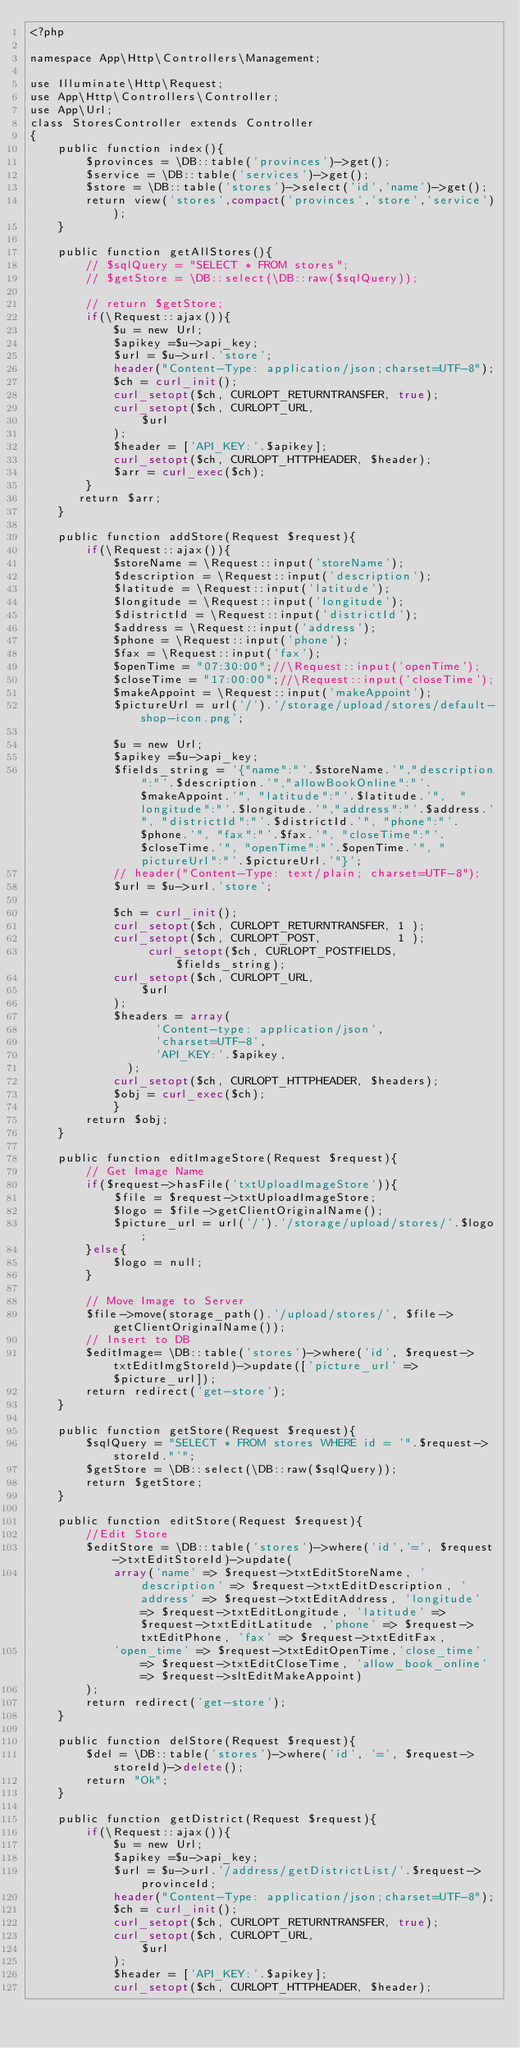Convert code to text. <code><loc_0><loc_0><loc_500><loc_500><_PHP_><?php

namespace App\Http\Controllers\Management;

use Illuminate\Http\Request;
use App\Http\Controllers\Controller;
use App\Url;
class StoresController extends Controller
{
    public function index(){
        $provinces = \DB::table('provinces')->get();
        $service = \DB::table('services')->get();
        $store = \DB::table('stores')->select('id','name')->get();
        return view('stores',compact('provinces','store','service'));
    }    

    public function getAllStores(){
        // $sqlQuery = "SELECT * FROM stores";
        // $getStore = \DB::select(\DB::raw($sqlQuery));             
        
        // return $getStore;
        if(\Request::ajax()){
            $u = new Url;
            $apikey =$u->api_key;
            $url = $u->url.'store';
            header("Content-Type: application/json;charset=UTF-8");              
            $ch = curl_init();
            curl_setopt($ch, CURLOPT_RETURNTRANSFER, true);
            curl_setopt($ch, CURLOPT_URL,
                $url
            );
            $header = ['API_KEY:'.$apikey];
            curl_setopt($ch, CURLOPT_HTTPHEADER, $header);
            $arr = curl_exec($ch);
        }
       return $arr;
    }

    public function addStore(Request $request){
        if(\Request::ajax()){
            $storeName = \Request::input('storeName');
            $description = \Request::input('description');
            $latitude = \Request::input('latitude');
            $longitude = \Request::input('longitude');
            $districtId = \Request::input('districtId');
            $address = \Request::input('address');
            $phone = \Request::input('phone');
            $fax = \Request::input('fax');
            $openTime = "07:30:00";//\Request::input('openTime');
            $closeTime = "17:00:00";//\Request::input('closeTime');
            $makeAppoint = \Request::input('makeAppoint');  
            $pictureUrl = url('/').'/storage/upload/stores/default-shop-icon.png';
            
            $u = new Url;
            $apikey =$u->api_key;
            $fields_string = '{"name":"'.$storeName.'","description":"'.$description.'","allowBookOnline":"'.$makeAppoint.'", "latitude":"'.$latitude.'",  "longitude":"'.$longitude.'","address":"'.$address.'", "districtId":"'.$districtId.'", "phone":"'.$phone.'", "fax":"'.$fax.'", "closeTime":"'.$closeTime.'", "openTime":"'.$openTime.'", "pictureUrl":"'.$pictureUrl.'"}';                   
            // header("Content-Type: text/plain; charset=UTF-8");
            $url = $u->url.'store';
     
            $ch = curl_init();
            curl_setopt($ch, CURLOPT_RETURNTRANSFER, 1 );
            curl_setopt($ch, CURLOPT_POST,           1 );
                 curl_setopt($ch, CURLOPT_POSTFIELDS, $fields_string);
            curl_setopt($ch, CURLOPT_URL,
                $url
            );
            $headers = array(
                  'Content-type: application/json',
                  'charset=UTF-8',
                  'API_KEY:'.$apikey,
              );
            curl_setopt($ch, CURLOPT_HTTPHEADER, $headers);
            $obj = curl_exec($ch);
            }
        return $obj;
    }

    public function editImageStore(Request $request){
        // Get Image Name
        if($request->hasFile('txtUploadImageStore')){
            $file = $request->txtUploadImageStore;            
            $logo = $file->getClientOriginalName();
            $picture_url = url('/').'/storage/upload/stores/'.$logo;
        }else{
            $logo = null;
        }
        
        // Move Image to Server
        $file->move(storage_path().'/upload/stores/', $file->getClientOriginalName());
        // Insert to DB
        $editImage= \DB::table('stores')->where('id', $request->txtEditImgStoreId)->update(['picture_url' => $picture_url]);
        return redirect('get-store');     
    }

    public function getStore(Request $request){
        $sqlQuery = "SELECT * FROM stores WHERE id = '".$request->storeId."'";
        $getStore = \DB::select(\DB::raw($sqlQuery));                                    
        return $getStore;
    }

    public function editStore(Request $request){     
        //Edit Store
        $editStore = \DB::table('stores')->where('id','=', $request->txtEditStoreId)->update(
            array('name' => $request->txtEditStoreName, 'description' => $request->txtEditDescription, 'address' => $request->txtEditAddress, 'longitude' => $request->txtEditLongitude, 'latitude' => $request->txtEditLatitude ,'phone' => $request->txtEditPhone, 'fax' => $request->txtEditFax,
            'open_time' => $request->txtEditOpenTime,'close_time' => $request->txtEditCloseTime, 'allow_book_online' => $request->sltEditMakeAppoint)
        );       
        return redirect('get-store');
    }

    public function delStore(Request $request){
        $del = \DB::table('stores')->where('id', '=', $request->storeId)->delete();
        return "Ok";
    }

    public function getDistrict(Request $request){
        if(\Request::ajax()){
            $u = new Url;
            $apikey =$u->api_key;
            $url = $u->url.'/address/getDistrictList/'.$request->provinceId;
            header("Content-Type: application/json;charset=UTF-8");              
            $ch = curl_init();
            curl_setopt($ch, CURLOPT_RETURNTRANSFER, true);
            curl_setopt($ch, CURLOPT_URL,
                $url
            );
            $header = ['API_KEY:'.$apikey];
            curl_setopt($ch, CURLOPT_HTTPHEADER, $header);</code> 